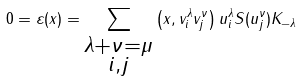<formula> <loc_0><loc_0><loc_500><loc_500>0 = \varepsilon ( x ) = \sum _ { \substack { \lambda + \nu = \mu \\ i , j } } \left ( x , v _ { i } ^ { \lambda } v _ { j } ^ { \nu } \right ) u _ { i } ^ { \lambda } S ( u _ { j } ^ { \nu } ) K _ { - \lambda }</formula> 